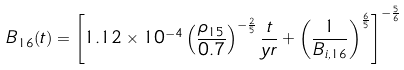Convert formula to latex. <formula><loc_0><loc_0><loc_500><loc_500>B _ { 1 6 } ( t ) = \left [ 1 . 1 2 \times 1 0 ^ { - 4 } \left ( \frac { \rho _ { 1 5 } } { 0 . 7 } \right ) ^ { - \frac { 2 } { 5 } } \frac { t } { y r } + \left ( \frac { 1 } { B _ { i , 1 6 } } \right ) ^ { \frac { 6 } { 5 } } \right ] ^ { - \frac { 5 } { 6 } }</formula> 